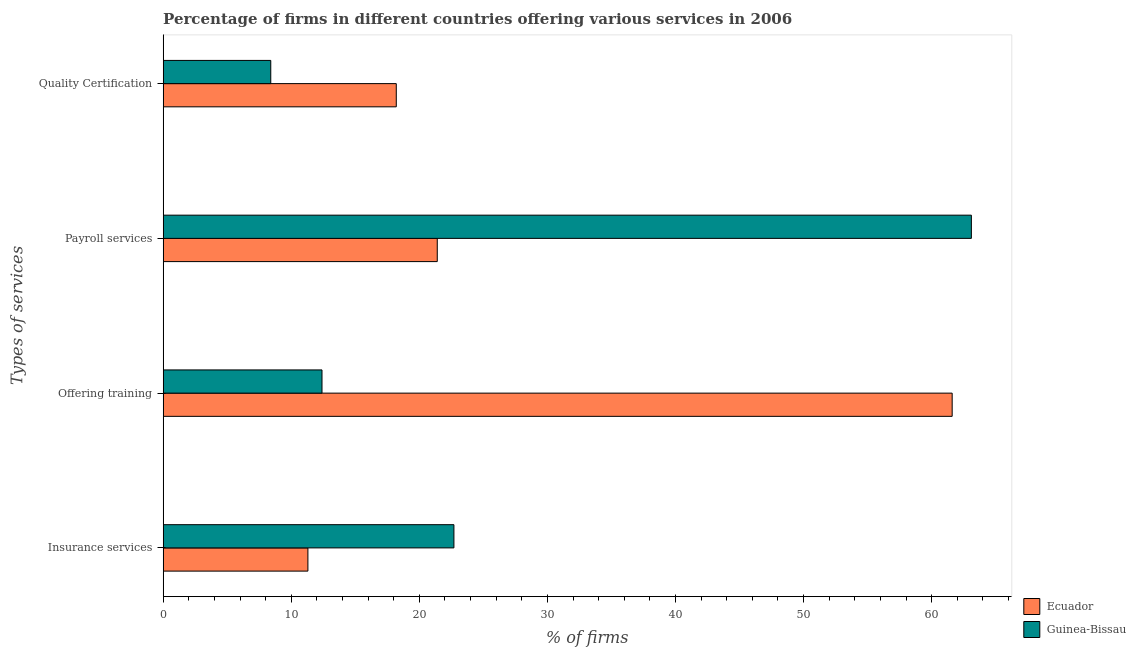How many different coloured bars are there?
Offer a very short reply. 2. Are the number of bars per tick equal to the number of legend labels?
Offer a terse response. Yes. Are the number of bars on each tick of the Y-axis equal?
Provide a succinct answer. Yes. How many bars are there on the 2nd tick from the top?
Keep it short and to the point. 2. How many bars are there on the 4th tick from the bottom?
Make the answer very short. 2. What is the label of the 3rd group of bars from the top?
Your answer should be compact. Offering training. What is the percentage of firms offering training in Ecuador?
Give a very brief answer. 61.6. Across all countries, what is the maximum percentage of firms offering insurance services?
Ensure brevity in your answer.  22.7. In which country was the percentage of firms offering payroll services maximum?
Give a very brief answer. Guinea-Bissau. In which country was the percentage of firms offering payroll services minimum?
Give a very brief answer. Ecuador. What is the total percentage of firms offering training in the graph?
Give a very brief answer. 74. What is the difference between the percentage of firms offering payroll services in Ecuador and that in Guinea-Bissau?
Your answer should be compact. -41.7. What is the difference between the percentage of firms offering quality certification in Ecuador and the percentage of firms offering payroll services in Guinea-Bissau?
Your answer should be very brief. -44.9. What is the average percentage of firms offering quality certification per country?
Make the answer very short. 13.3. What is the difference between the percentage of firms offering quality certification and percentage of firms offering insurance services in Ecuador?
Your answer should be very brief. 6.9. What is the ratio of the percentage of firms offering training in Ecuador to that in Guinea-Bissau?
Your answer should be compact. 4.97. What is the difference between the highest and the second highest percentage of firms offering training?
Offer a terse response. 49.2. What is the difference between the highest and the lowest percentage of firms offering insurance services?
Make the answer very short. 11.4. Is the sum of the percentage of firms offering insurance services in Ecuador and Guinea-Bissau greater than the maximum percentage of firms offering quality certification across all countries?
Ensure brevity in your answer.  Yes. What does the 1st bar from the top in Quality Certification represents?
Your answer should be very brief. Guinea-Bissau. What does the 2nd bar from the bottom in Offering training represents?
Provide a succinct answer. Guinea-Bissau. Is it the case that in every country, the sum of the percentage of firms offering insurance services and percentage of firms offering training is greater than the percentage of firms offering payroll services?
Keep it short and to the point. No. How many countries are there in the graph?
Provide a succinct answer. 2. What is the difference between two consecutive major ticks on the X-axis?
Offer a very short reply. 10. Are the values on the major ticks of X-axis written in scientific E-notation?
Your response must be concise. No. Does the graph contain any zero values?
Give a very brief answer. No. Does the graph contain grids?
Your answer should be very brief. No. Where does the legend appear in the graph?
Keep it short and to the point. Bottom right. What is the title of the graph?
Keep it short and to the point. Percentage of firms in different countries offering various services in 2006. What is the label or title of the X-axis?
Make the answer very short. % of firms. What is the label or title of the Y-axis?
Give a very brief answer. Types of services. What is the % of firms of Guinea-Bissau in Insurance services?
Keep it short and to the point. 22.7. What is the % of firms in Ecuador in Offering training?
Your answer should be very brief. 61.6. What is the % of firms of Guinea-Bissau in Offering training?
Offer a very short reply. 12.4. What is the % of firms in Ecuador in Payroll services?
Provide a succinct answer. 21.4. What is the % of firms of Guinea-Bissau in Payroll services?
Provide a succinct answer. 63.1. What is the % of firms of Ecuador in Quality Certification?
Ensure brevity in your answer.  18.2. Across all Types of services, what is the maximum % of firms in Ecuador?
Ensure brevity in your answer.  61.6. Across all Types of services, what is the maximum % of firms of Guinea-Bissau?
Your answer should be compact. 63.1. Across all Types of services, what is the minimum % of firms of Ecuador?
Keep it short and to the point. 11.3. What is the total % of firms in Ecuador in the graph?
Offer a terse response. 112.5. What is the total % of firms of Guinea-Bissau in the graph?
Provide a succinct answer. 106.6. What is the difference between the % of firms in Ecuador in Insurance services and that in Offering training?
Your answer should be very brief. -50.3. What is the difference between the % of firms in Guinea-Bissau in Insurance services and that in Offering training?
Offer a very short reply. 10.3. What is the difference between the % of firms of Ecuador in Insurance services and that in Payroll services?
Provide a short and direct response. -10.1. What is the difference between the % of firms in Guinea-Bissau in Insurance services and that in Payroll services?
Your answer should be compact. -40.4. What is the difference between the % of firms in Ecuador in Offering training and that in Payroll services?
Your response must be concise. 40.2. What is the difference between the % of firms in Guinea-Bissau in Offering training and that in Payroll services?
Give a very brief answer. -50.7. What is the difference between the % of firms in Ecuador in Offering training and that in Quality Certification?
Keep it short and to the point. 43.4. What is the difference between the % of firms in Ecuador in Payroll services and that in Quality Certification?
Give a very brief answer. 3.2. What is the difference between the % of firms of Guinea-Bissau in Payroll services and that in Quality Certification?
Your answer should be very brief. 54.7. What is the difference between the % of firms in Ecuador in Insurance services and the % of firms in Guinea-Bissau in Offering training?
Ensure brevity in your answer.  -1.1. What is the difference between the % of firms in Ecuador in Insurance services and the % of firms in Guinea-Bissau in Payroll services?
Give a very brief answer. -51.8. What is the difference between the % of firms in Ecuador in Insurance services and the % of firms in Guinea-Bissau in Quality Certification?
Give a very brief answer. 2.9. What is the difference between the % of firms in Ecuador in Offering training and the % of firms in Guinea-Bissau in Quality Certification?
Make the answer very short. 53.2. What is the difference between the % of firms of Ecuador in Payroll services and the % of firms of Guinea-Bissau in Quality Certification?
Your response must be concise. 13. What is the average % of firms of Ecuador per Types of services?
Keep it short and to the point. 28.12. What is the average % of firms of Guinea-Bissau per Types of services?
Give a very brief answer. 26.65. What is the difference between the % of firms in Ecuador and % of firms in Guinea-Bissau in Insurance services?
Keep it short and to the point. -11.4. What is the difference between the % of firms of Ecuador and % of firms of Guinea-Bissau in Offering training?
Provide a succinct answer. 49.2. What is the difference between the % of firms in Ecuador and % of firms in Guinea-Bissau in Payroll services?
Offer a very short reply. -41.7. What is the difference between the % of firms of Ecuador and % of firms of Guinea-Bissau in Quality Certification?
Your response must be concise. 9.8. What is the ratio of the % of firms of Ecuador in Insurance services to that in Offering training?
Your response must be concise. 0.18. What is the ratio of the % of firms of Guinea-Bissau in Insurance services to that in Offering training?
Provide a short and direct response. 1.83. What is the ratio of the % of firms in Ecuador in Insurance services to that in Payroll services?
Provide a short and direct response. 0.53. What is the ratio of the % of firms in Guinea-Bissau in Insurance services to that in Payroll services?
Offer a terse response. 0.36. What is the ratio of the % of firms in Ecuador in Insurance services to that in Quality Certification?
Your answer should be compact. 0.62. What is the ratio of the % of firms in Guinea-Bissau in Insurance services to that in Quality Certification?
Provide a short and direct response. 2.7. What is the ratio of the % of firms in Ecuador in Offering training to that in Payroll services?
Your answer should be compact. 2.88. What is the ratio of the % of firms in Guinea-Bissau in Offering training to that in Payroll services?
Your answer should be very brief. 0.2. What is the ratio of the % of firms in Ecuador in Offering training to that in Quality Certification?
Make the answer very short. 3.38. What is the ratio of the % of firms of Guinea-Bissau in Offering training to that in Quality Certification?
Keep it short and to the point. 1.48. What is the ratio of the % of firms of Ecuador in Payroll services to that in Quality Certification?
Make the answer very short. 1.18. What is the ratio of the % of firms in Guinea-Bissau in Payroll services to that in Quality Certification?
Your response must be concise. 7.51. What is the difference between the highest and the second highest % of firms in Ecuador?
Your response must be concise. 40.2. What is the difference between the highest and the second highest % of firms in Guinea-Bissau?
Your response must be concise. 40.4. What is the difference between the highest and the lowest % of firms of Ecuador?
Your response must be concise. 50.3. What is the difference between the highest and the lowest % of firms of Guinea-Bissau?
Offer a terse response. 54.7. 